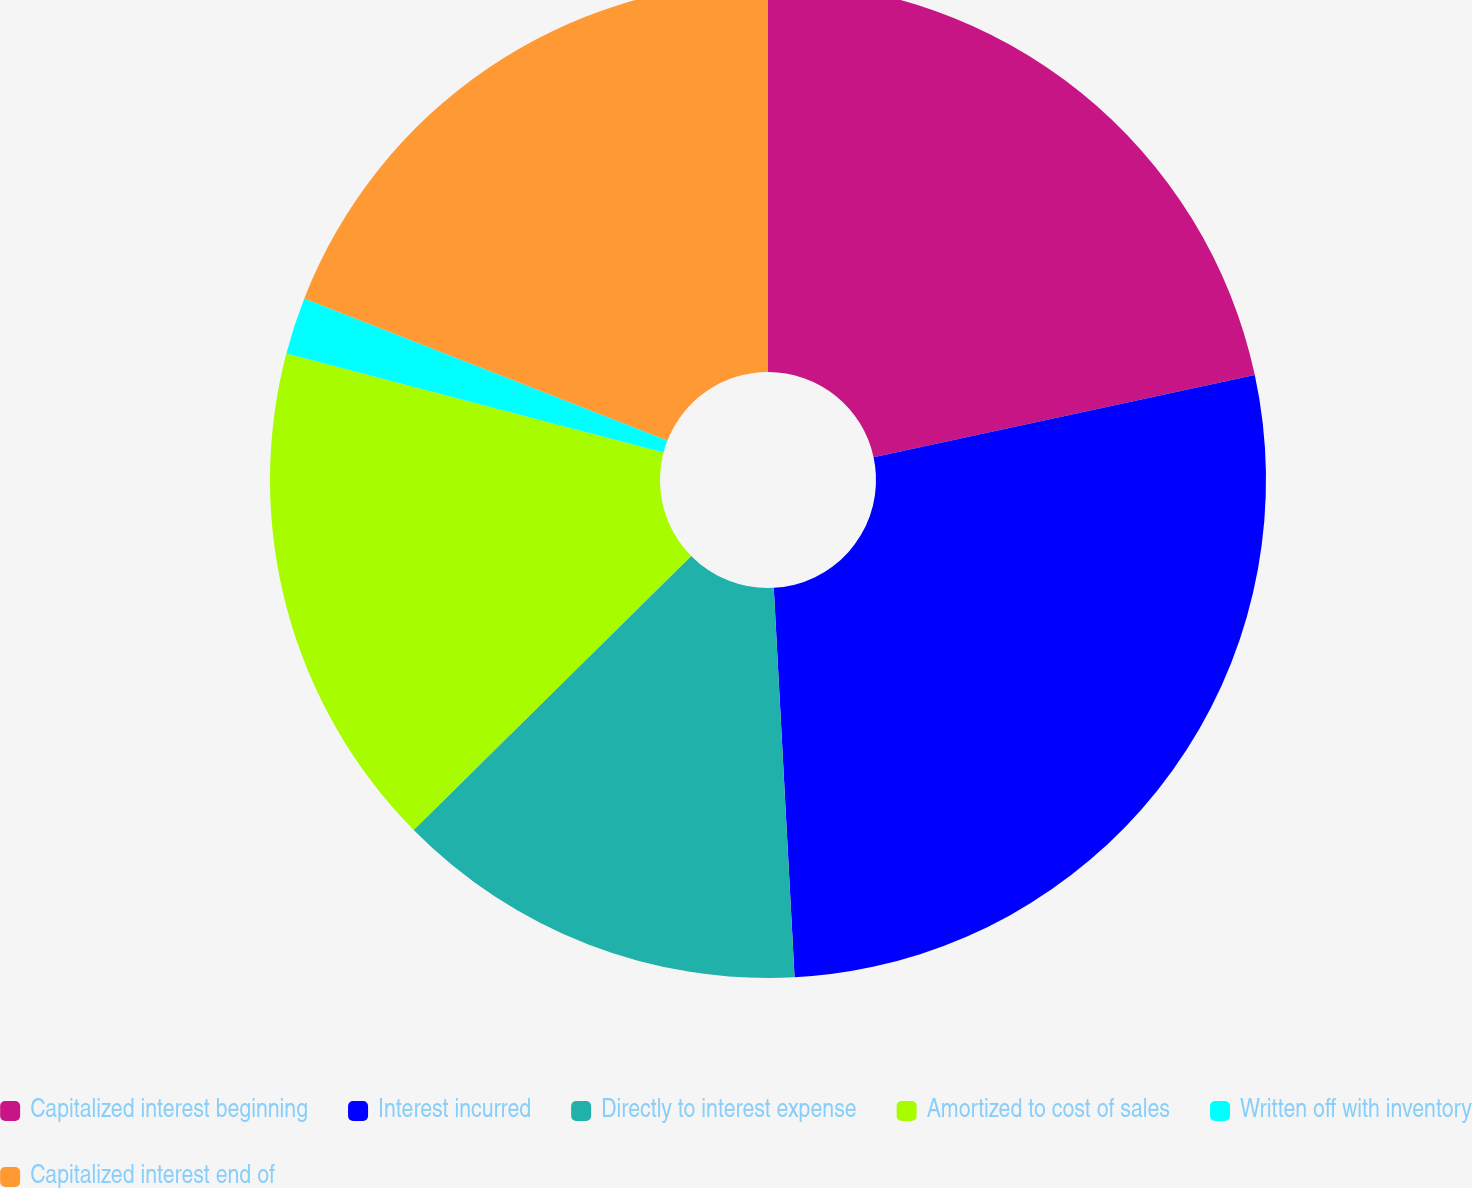Convert chart to OTSL. <chart><loc_0><loc_0><loc_500><loc_500><pie_chart><fcel>Capitalized interest beginning<fcel>Interest incurred<fcel>Directly to interest expense<fcel>Amortized to cost of sales<fcel>Written off with inventory<fcel>Capitalized interest end of<nl><fcel>21.62%<fcel>27.53%<fcel>13.45%<fcel>16.49%<fcel>1.85%<fcel>19.06%<nl></chart> 